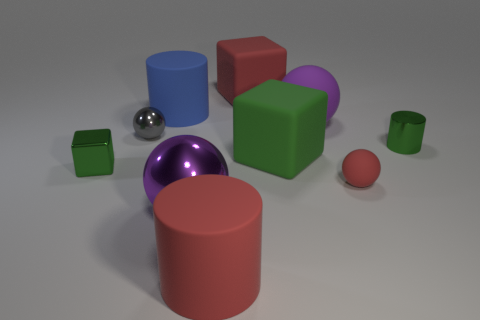Subtract all small shiny cylinders. How many cylinders are left? 2 Subtract all red spheres. How many spheres are left? 3 Subtract all green blocks. How many purple balls are left? 2 Add 4 matte cylinders. How many matte cylinders exist? 6 Subtract 0 brown spheres. How many objects are left? 10 Subtract all cubes. How many objects are left? 7 Subtract all blue spheres. Subtract all red cylinders. How many spheres are left? 4 Subtract all small objects. Subtract all cylinders. How many objects are left? 3 Add 9 green shiny blocks. How many green shiny blocks are left? 10 